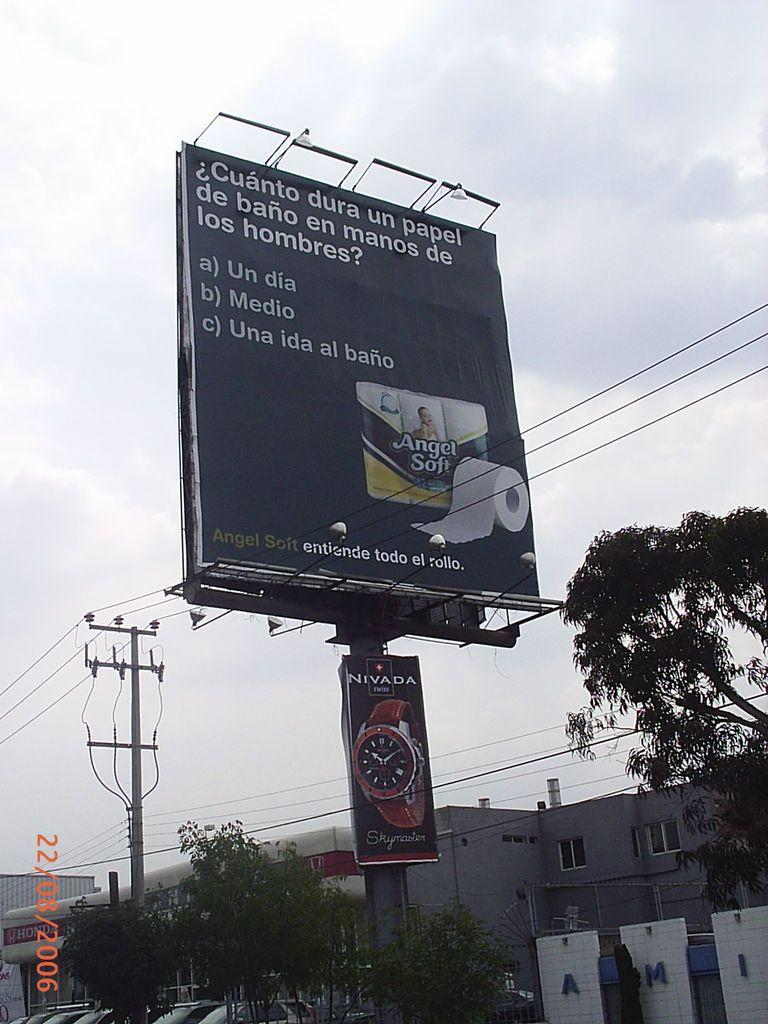<image>
Share a concise interpretation of the image provided. A toilet paper brand claims to last the whole roll, even in the hands of a man. 